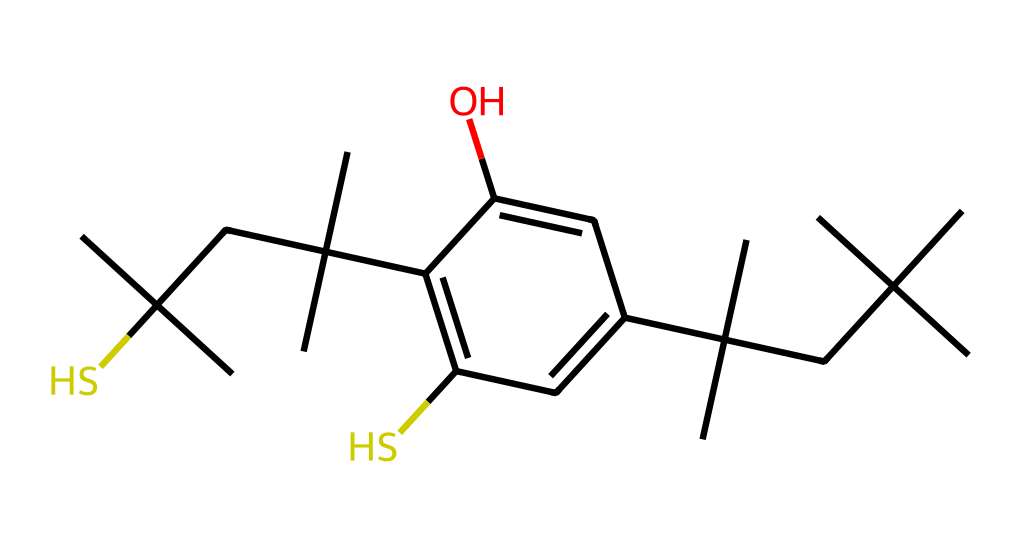how many sulfur atoms are in this structure? By examining the SMILES representation, we can identify the sulfur atoms denoted by 'S'. In this structure, there are two 'S' present.
Answer: 2 what is the degree of substitution for the aromatic ring in this compound? The aromatic ring is represented by 'c' in the SMILES, where it has substituents attached. The analysis shows it has two alkyl groups (CC(C)(C)) and a hydroxyl group (O), resulting in the ring being fully substituted as each carbon has substituents.
Answer: fully substituted how many tertiary butyl groups are present in this compound? The structure includes multiple instances of 'C(C)(C)', which indicates the presence of tertiary butyl groups. Upon counting, there are four distinct tertiary butyl groups in the C(C)(C) configurations.
Answer: 4 what functional groups are present in this organosulfur antioxidant? An analysis of the SMILES representation shows that the compound contains hydroxyl (–OH) and thioether (–S–) functional groups, identified by 'O' and 'S' respectively in the structure.
Answer: hydroxyl and thioether what role do organosulfur compounds play in lubricants? Organosulfur compounds like this one are utilized as antioxidants in lubricants, as they help in preventing oxidation and degradation of lubricant oils, thus enhancing performance.
Answer: antioxidants 